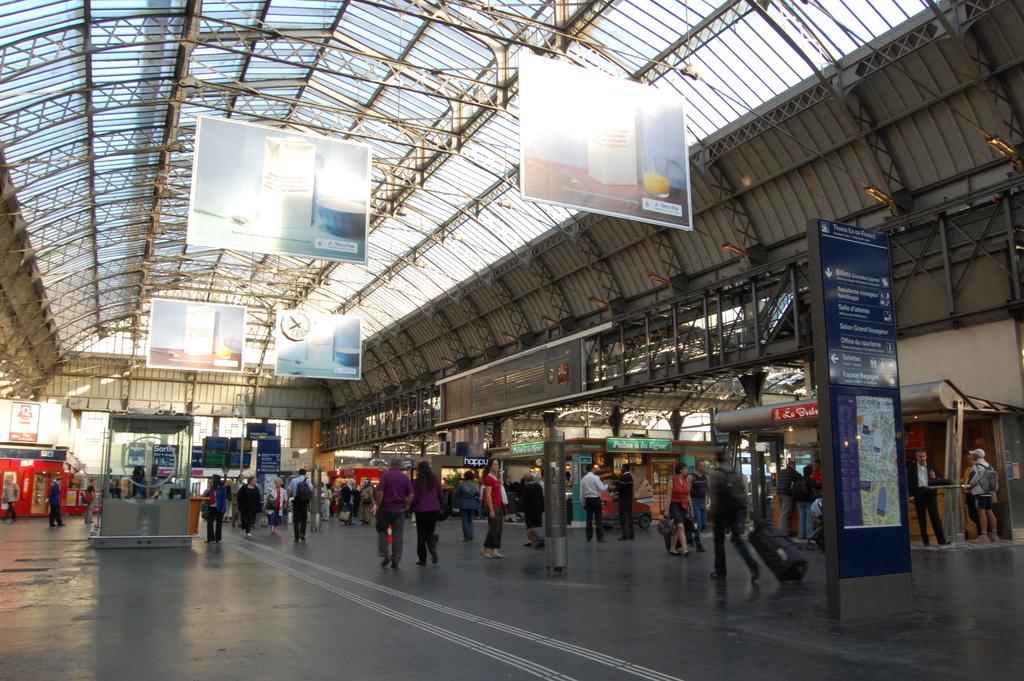How would you summarize this image in a sentence or two? In this image we can see persons, pillars, advertisements, stores, name boards, iron bars, charts, clock and roof. 